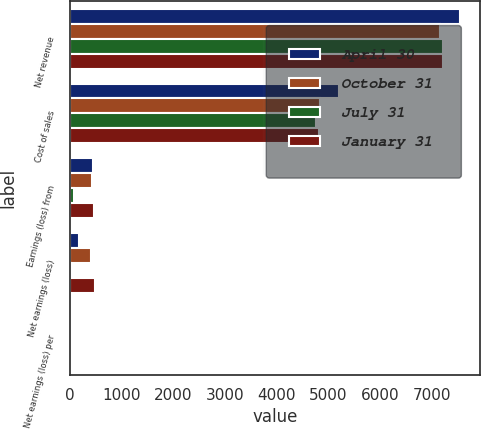Convert chart. <chart><loc_0><loc_0><loc_500><loc_500><stacked_bar_chart><ecel><fcel>Net revenue<fcel>Cost of sales<fcel>Earnings (loss) from<fcel>Net earnings (loss)<fcel>Net earnings (loss) per<nl><fcel>April 30<fcel>7553<fcel>5207<fcel>456<fcel>177<fcel>0.13<nl><fcel>October 31<fcel>7150<fcel>4845<fcel>434<fcel>419<fcel>0.3<nl><fcel>July 31<fcel>7217<fcel>4768<fcel>76<fcel>27<fcel>0.02<nl><fcel>January 31<fcel>7215<fcel>4822<fcel>460<fcel>480<fcel>0.36<nl></chart> 